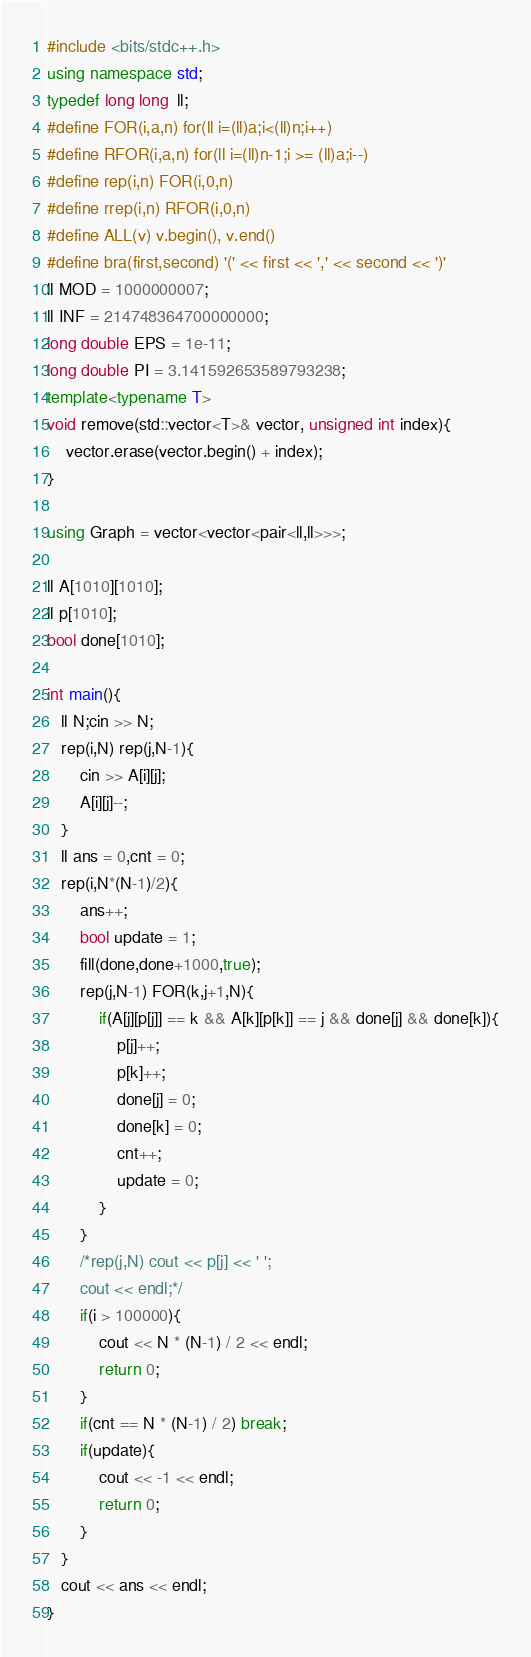Convert code to text. <code><loc_0><loc_0><loc_500><loc_500><_C++_>#include <bits/stdc++.h>
using namespace std;
typedef long long  ll;
#define FOR(i,a,n) for(ll i=(ll)a;i<(ll)n;i++)
#define RFOR(i,a,n) for(ll i=(ll)n-1;i >= (ll)a;i--)
#define rep(i,n) FOR(i,0,n)
#define rrep(i,n) RFOR(i,0,n)
#define ALL(v) v.begin(), v.end()
#define bra(first,second) '(' << first << ',' << second << ')'
ll MOD = 1000000007;
ll INF = 214748364700000000;
long double EPS = 1e-11;
long double PI = 3.141592653589793238;
template<typename T>
void remove(std::vector<T>& vector, unsigned int index){
    vector.erase(vector.begin() + index);
}

using Graph = vector<vector<pair<ll,ll>>>;

ll A[1010][1010];
ll p[1010];
bool done[1010];

int main(){
   ll N;cin >> N;
   rep(i,N) rep(j,N-1){
       cin >> A[i][j];
       A[i][j]--;
   }
   ll ans = 0,cnt = 0;
   rep(i,N*(N-1)/2){
       ans++;
       bool update = 1;
       fill(done,done+1000,true);
       rep(j,N-1) FOR(k,j+1,N){
           if(A[j][p[j]] == k && A[k][p[k]] == j && done[j] && done[k]){
               p[j]++;
               p[k]++;
               done[j] = 0;
               done[k] = 0;
               cnt++;
               update = 0;
           }
       }
       /*rep(j,N) cout << p[j] << ' ';
       cout << endl;*/
       if(i > 100000){
           cout << N * (N-1) / 2 << endl;
           return 0;
       }
       if(cnt == N * (N-1) / 2) break;
       if(update){
           cout << -1 << endl;
           return 0;
       }
   }
   cout << ans << endl;
}
</code> 